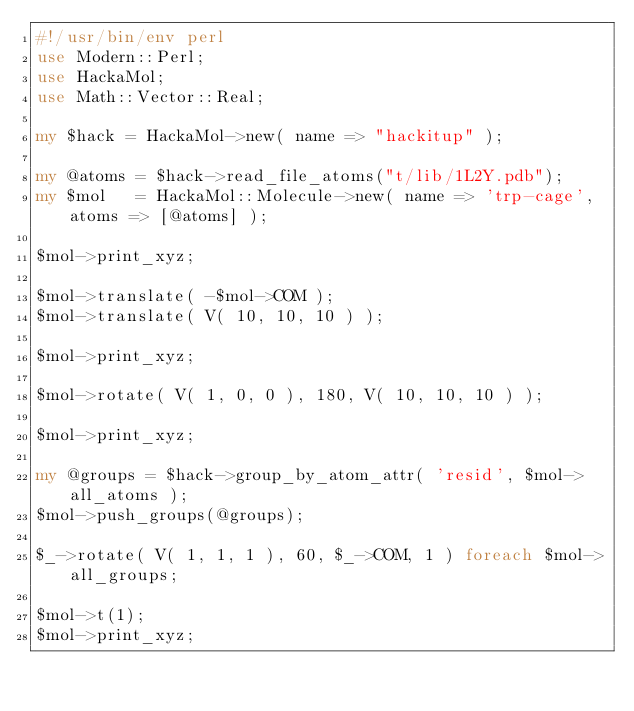Convert code to text. <code><loc_0><loc_0><loc_500><loc_500><_Perl_>#!/usr/bin/env perl
use Modern::Perl;
use HackaMol;
use Math::Vector::Real;

my $hack = HackaMol->new( name => "hackitup" );

my @atoms = $hack->read_file_atoms("t/lib/1L2Y.pdb");
my $mol   = HackaMol::Molecule->new( name => 'trp-cage', atoms => [@atoms] );

$mol->print_xyz;

$mol->translate( -$mol->COM );
$mol->translate( V( 10, 10, 10 ) );

$mol->print_xyz;

$mol->rotate( V( 1, 0, 0 ), 180, V( 10, 10, 10 ) );

$mol->print_xyz;

my @groups = $hack->group_by_atom_attr( 'resid', $mol->all_atoms );
$mol->push_groups(@groups);

$_->rotate( V( 1, 1, 1 ), 60, $_->COM, 1 ) foreach $mol->all_groups;

$mol->t(1);
$mol->print_xyz;

</code> 